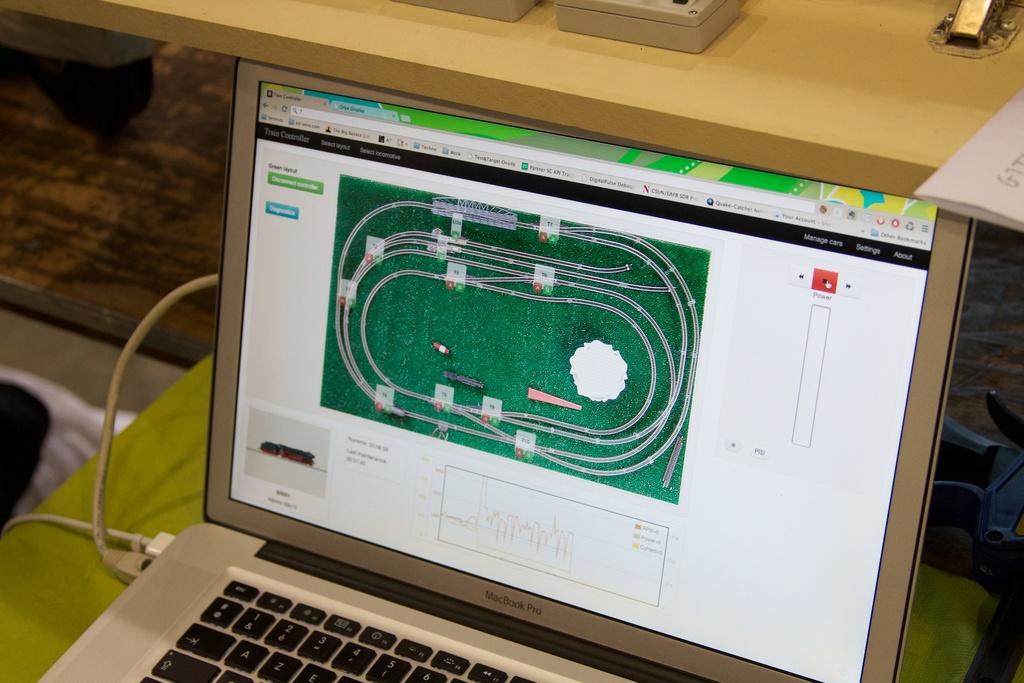Can you see what´s the first letter on the white paper on top?
Provide a short and direct response. G. 